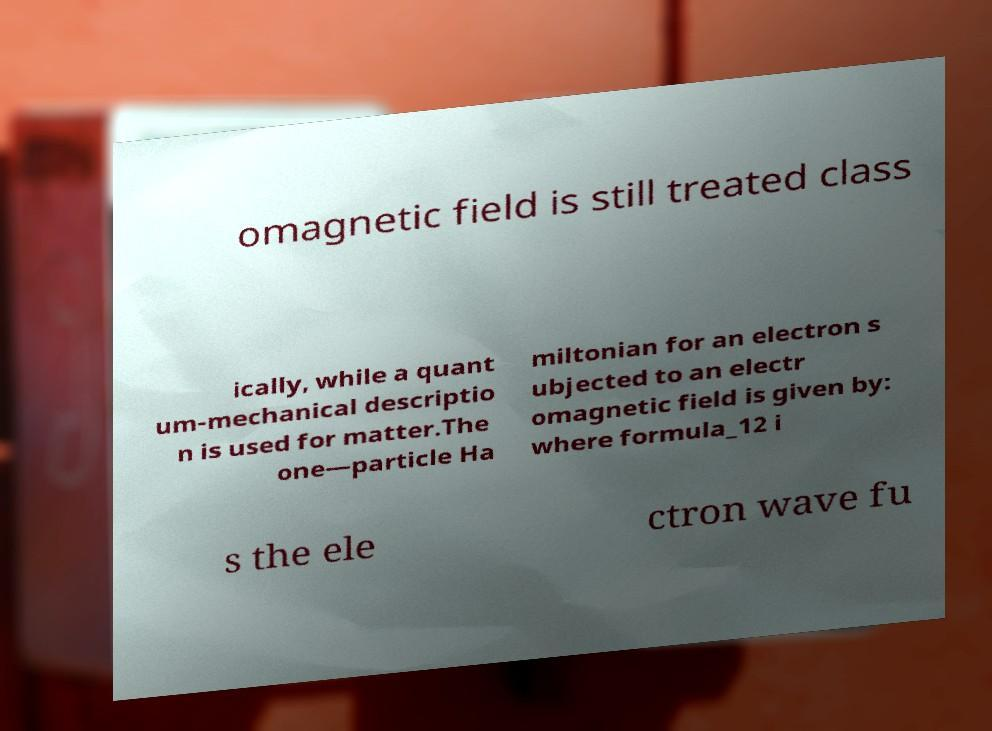Could you extract and type out the text from this image? omagnetic field is still treated class ically, while a quant um-mechanical descriptio n is used for matter.The one—particle Ha miltonian for an electron s ubjected to an electr omagnetic field is given by: where formula_12 i s the ele ctron wave fu 